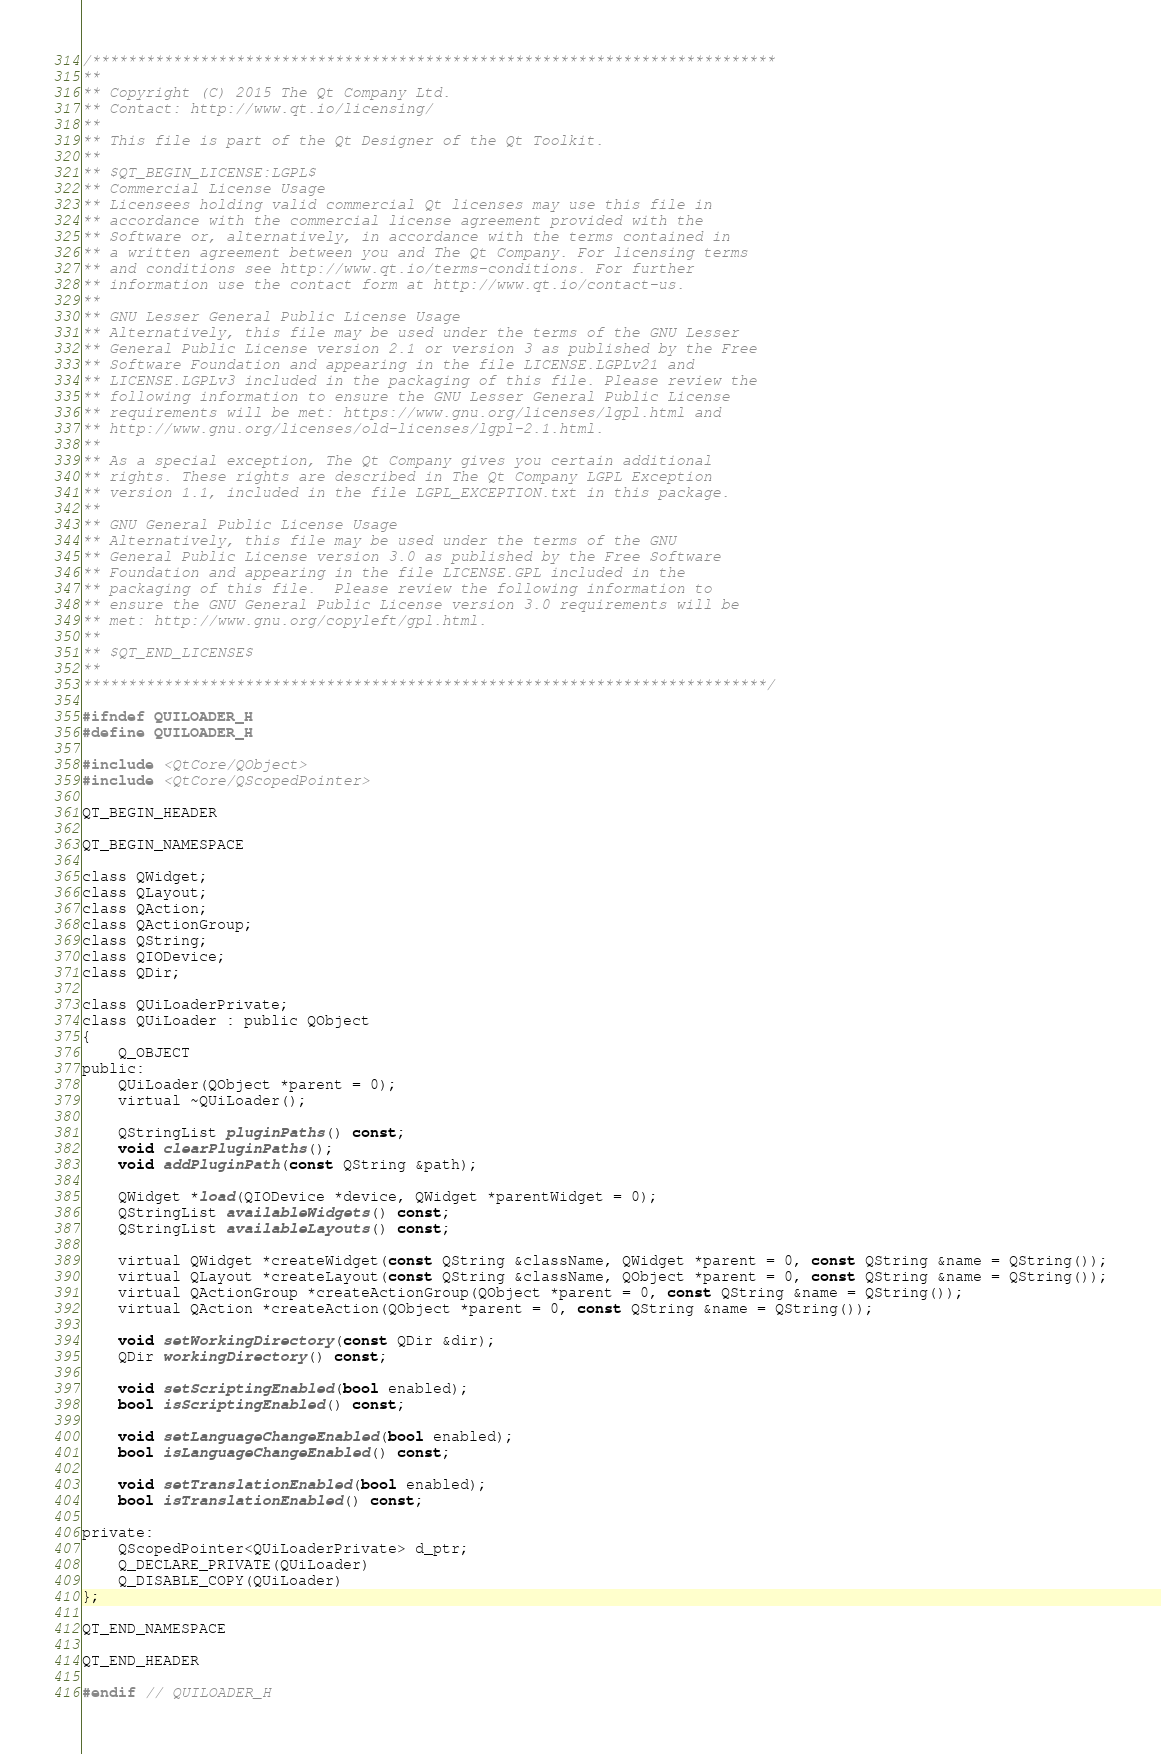Convert code to text. <code><loc_0><loc_0><loc_500><loc_500><_C_>/****************************************************************************
**
** Copyright (C) 2015 The Qt Company Ltd.
** Contact: http://www.qt.io/licensing/
**
** This file is part of the Qt Designer of the Qt Toolkit.
**
** $QT_BEGIN_LICENSE:LGPL$
** Commercial License Usage
** Licensees holding valid commercial Qt licenses may use this file in
** accordance with the commercial license agreement provided with the
** Software or, alternatively, in accordance with the terms contained in
** a written agreement between you and The Qt Company. For licensing terms
** and conditions see http://www.qt.io/terms-conditions. For further
** information use the contact form at http://www.qt.io/contact-us.
**
** GNU Lesser General Public License Usage
** Alternatively, this file may be used under the terms of the GNU Lesser
** General Public License version 2.1 or version 3 as published by the Free
** Software Foundation and appearing in the file LICENSE.LGPLv21 and
** LICENSE.LGPLv3 included in the packaging of this file. Please review the
** following information to ensure the GNU Lesser General Public License
** requirements will be met: https://www.gnu.org/licenses/lgpl.html and
** http://www.gnu.org/licenses/old-licenses/lgpl-2.1.html.
**
** As a special exception, The Qt Company gives you certain additional
** rights. These rights are described in The Qt Company LGPL Exception
** version 1.1, included in the file LGPL_EXCEPTION.txt in this package.
**
** GNU General Public License Usage
** Alternatively, this file may be used under the terms of the GNU
** General Public License version 3.0 as published by the Free Software
** Foundation and appearing in the file LICENSE.GPL included in the
** packaging of this file.  Please review the following information to
** ensure the GNU General Public License version 3.0 requirements will be
** met: http://www.gnu.org/copyleft/gpl.html.
**
** $QT_END_LICENSE$
**
****************************************************************************/

#ifndef QUILOADER_H
#define QUILOADER_H

#include <QtCore/QObject>
#include <QtCore/QScopedPointer>

QT_BEGIN_HEADER

QT_BEGIN_NAMESPACE

class QWidget;
class QLayout;
class QAction;
class QActionGroup;
class QString;
class QIODevice;
class QDir;

class QUiLoaderPrivate;
class QUiLoader : public QObject
{
    Q_OBJECT
public:
    QUiLoader(QObject *parent = 0);
    virtual ~QUiLoader();

    QStringList pluginPaths() const;
    void clearPluginPaths();
    void addPluginPath(const QString &path);

    QWidget *load(QIODevice *device, QWidget *parentWidget = 0);
    QStringList availableWidgets() const;
    QStringList availableLayouts() const;

    virtual QWidget *createWidget(const QString &className, QWidget *parent = 0, const QString &name = QString());
    virtual QLayout *createLayout(const QString &className, QObject *parent = 0, const QString &name = QString());
    virtual QActionGroup *createActionGroup(QObject *parent = 0, const QString &name = QString());
    virtual QAction *createAction(QObject *parent = 0, const QString &name = QString());

    void setWorkingDirectory(const QDir &dir);
    QDir workingDirectory() const;

    void setScriptingEnabled(bool enabled);
    bool isScriptingEnabled() const;

    void setLanguageChangeEnabled(bool enabled);
    bool isLanguageChangeEnabled() const;

    void setTranslationEnabled(bool enabled);
    bool isTranslationEnabled() const;

private:
    QScopedPointer<QUiLoaderPrivate> d_ptr;
    Q_DECLARE_PRIVATE(QUiLoader)
    Q_DISABLE_COPY(QUiLoader)
};

QT_END_NAMESPACE

QT_END_HEADER

#endif // QUILOADER_H
</code> 